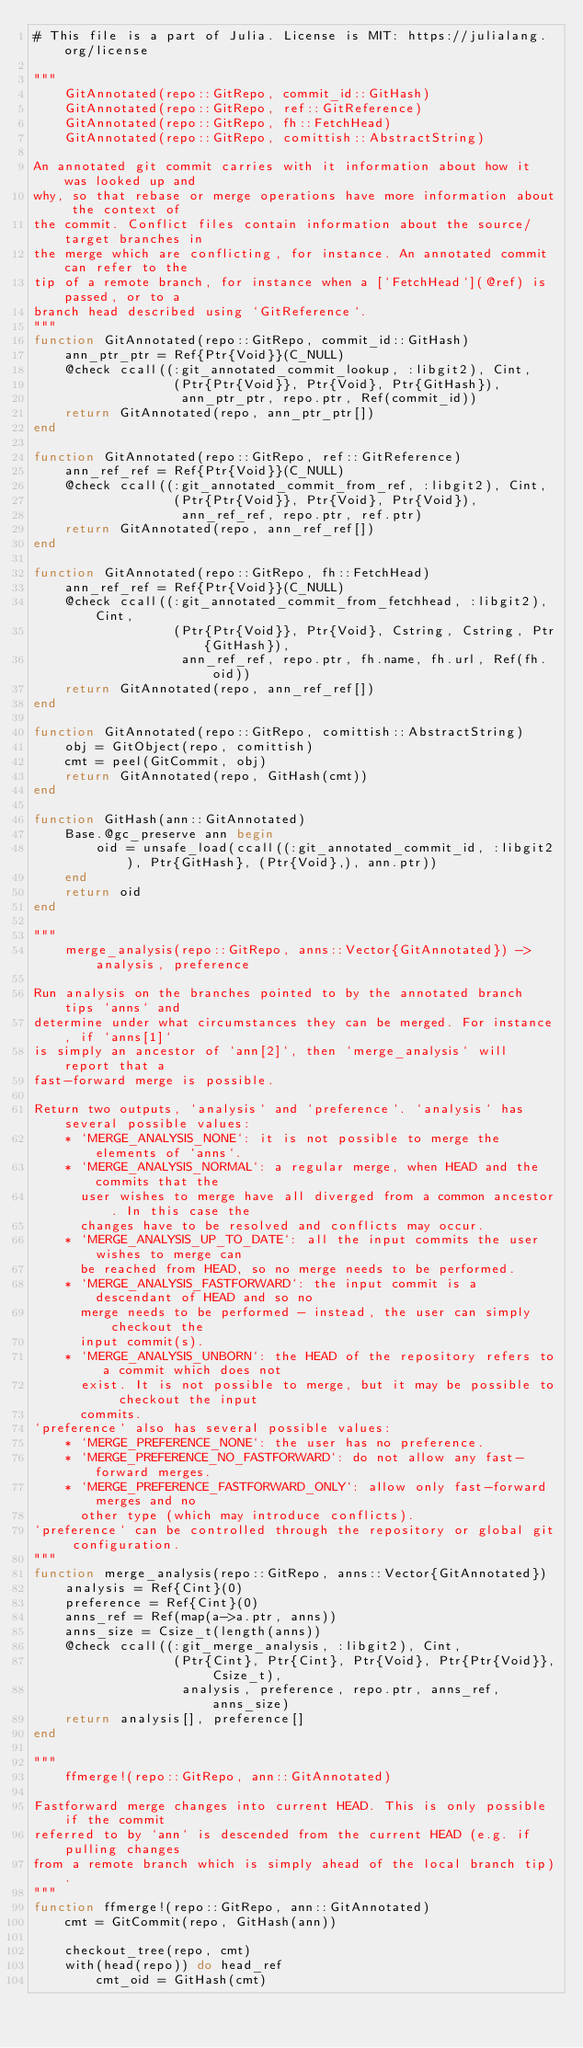Convert code to text. <code><loc_0><loc_0><loc_500><loc_500><_Julia_># This file is a part of Julia. License is MIT: https://julialang.org/license

"""
    GitAnnotated(repo::GitRepo, commit_id::GitHash)
    GitAnnotated(repo::GitRepo, ref::GitReference)
    GitAnnotated(repo::GitRepo, fh::FetchHead)
    GitAnnotated(repo::GitRepo, comittish::AbstractString)

An annotated git commit carries with it information about how it was looked up and
why, so that rebase or merge operations have more information about the context of
the commit. Conflict files contain information about the source/target branches in
the merge which are conflicting, for instance. An annotated commit can refer to the
tip of a remote branch, for instance when a [`FetchHead`](@ref) is passed, or to a
branch head described using `GitReference`.
"""
function GitAnnotated(repo::GitRepo, commit_id::GitHash)
    ann_ptr_ptr = Ref{Ptr{Void}}(C_NULL)
    @check ccall((:git_annotated_commit_lookup, :libgit2), Cint,
                  (Ptr{Ptr{Void}}, Ptr{Void}, Ptr{GitHash}),
                   ann_ptr_ptr, repo.ptr, Ref(commit_id))
    return GitAnnotated(repo, ann_ptr_ptr[])
end

function GitAnnotated(repo::GitRepo, ref::GitReference)
    ann_ref_ref = Ref{Ptr{Void}}(C_NULL)
    @check ccall((:git_annotated_commit_from_ref, :libgit2), Cint,
                  (Ptr{Ptr{Void}}, Ptr{Void}, Ptr{Void}),
                   ann_ref_ref, repo.ptr, ref.ptr)
    return GitAnnotated(repo, ann_ref_ref[])
end

function GitAnnotated(repo::GitRepo, fh::FetchHead)
    ann_ref_ref = Ref{Ptr{Void}}(C_NULL)
    @check ccall((:git_annotated_commit_from_fetchhead, :libgit2), Cint,
                  (Ptr{Ptr{Void}}, Ptr{Void}, Cstring, Cstring, Ptr{GitHash}),
                   ann_ref_ref, repo.ptr, fh.name, fh.url, Ref(fh.oid))
    return GitAnnotated(repo, ann_ref_ref[])
end

function GitAnnotated(repo::GitRepo, comittish::AbstractString)
    obj = GitObject(repo, comittish)
    cmt = peel(GitCommit, obj)
    return GitAnnotated(repo, GitHash(cmt))
end

function GitHash(ann::GitAnnotated)
    Base.@gc_preserve ann begin
        oid = unsafe_load(ccall((:git_annotated_commit_id, :libgit2), Ptr{GitHash}, (Ptr{Void},), ann.ptr))
    end
    return oid
end

"""
    merge_analysis(repo::GitRepo, anns::Vector{GitAnnotated}) -> analysis, preference

Run analysis on the branches pointed to by the annotated branch tips `anns` and
determine under what circumstances they can be merged. For instance, if `anns[1]`
is simply an ancestor of `ann[2]`, then `merge_analysis` will report that a
fast-forward merge is possible.

Return two outputs, `analysis` and `preference`. `analysis` has several possible values:
    * `MERGE_ANALYSIS_NONE`: it is not possible to merge the elements of `anns`.
    * `MERGE_ANALYSIS_NORMAL`: a regular merge, when HEAD and the commits that the
      user wishes to merge have all diverged from a common ancestor. In this case the
      changes have to be resolved and conflicts may occur.
    * `MERGE_ANALYSIS_UP_TO_DATE`: all the input commits the user wishes to merge can
      be reached from HEAD, so no merge needs to be performed.
    * `MERGE_ANALYSIS_FASTFORWARD`: the input commit is a descendant of HEAD and so no
      merge needs to be performed - instead, the user can simply checkout the
      input commit(s).
    * `MERGE_ANALYSIS_UNBORN`: the HEAD of the repository refers to a commit which does not
      exist. It is not possible to merge, but it may be possible to checkout the input
      commits.
`preference` also has several possible values:
    * `MERGE_PREFERENCE_NONE`: the user has no preference.
    * `MERGE_PREFERENCE_NO_FASTFORWARD`: do not allow any fast-forward merges.
    * `MERGE_PREFERENCE_FASTFORWARD_ONLY`: allow only fast-forward merges and no
      other type (which may introduce conflicts).
`preference` can be controlled through the repository or global git configuration.
"""
function merge_analysis(repo::GitRepo, anns::Vector{GitAnnotated})
    analysis = Ref{Cint}(0)
    preference = Ref{Cint}(0)
    anns_ref = Ref(map(a->a.ptr, anns))
    anns_size = Csize_t(length(anns))
    @check ccall((:git_merge_analysis, :libgit2), Cint,
                  (Ptr{Cint}, Ptr{Cint}, Ptr{Void}, Ptr{Ptr{Void}}, Csize_t),
                   analysis, preference, repo.ptr, anns_ref, anns_size)
    return analysis[], preference[]
end

"""
    ffmerge!(repo::GitRepo, ann::GitAnnotated)

Fastforward merge changes into current HEAD. This is only possible if the commit
referred to by `ann` is descended from the current HEAD (e.g. if pulling changes
from a remote branch which is simply ahead of the local branch tip).
"""
function ffmerge!(repo::GitRepo, ann::GitAnnotated)
    cmt = GitCommit(repo, GitHash(ann))

    checkout_tree(repo, cmt)
    with(head(repo)) do head_ref
        cmt_oid = GitHash(cmt)</code> 